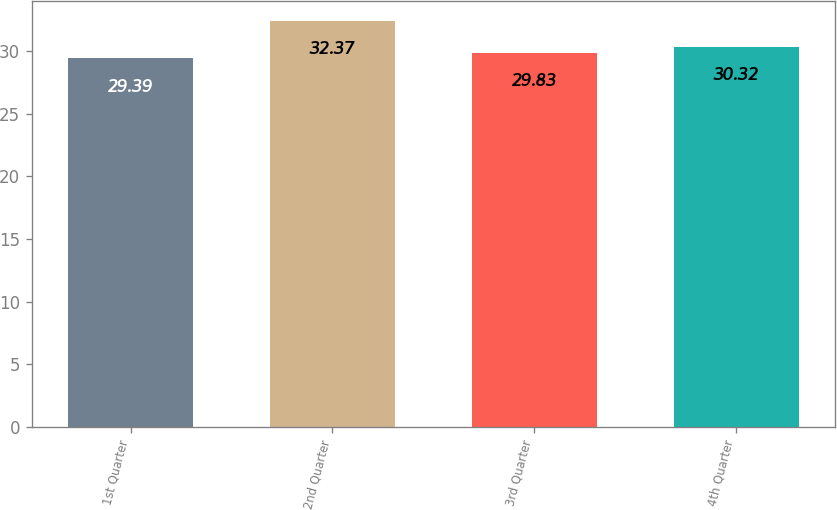Convert chart. <chart><loc_0><loc_0><loc_500><loc_500><bar_chart><fcel>1st Quarter<fcel>2nd Quarter<fcel>3rd Quarter<fcel>4th Quarter<nl><fcel>29.39<fcel>32.37<fcel>29.83<fcel>30.32<nl></chart> 